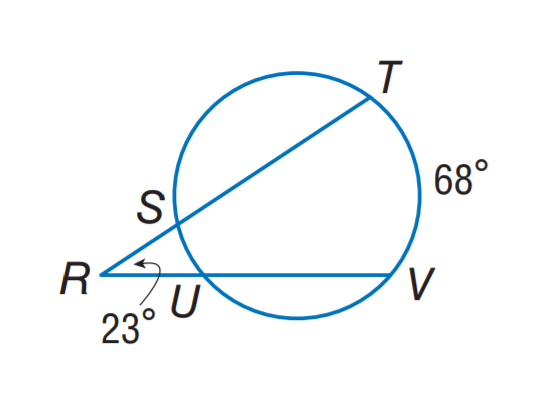Question: Find m \widehat S U.
Choices:
A. 22
B. 23
C. 34
D. 68
Answer with the letter. Answer: A 